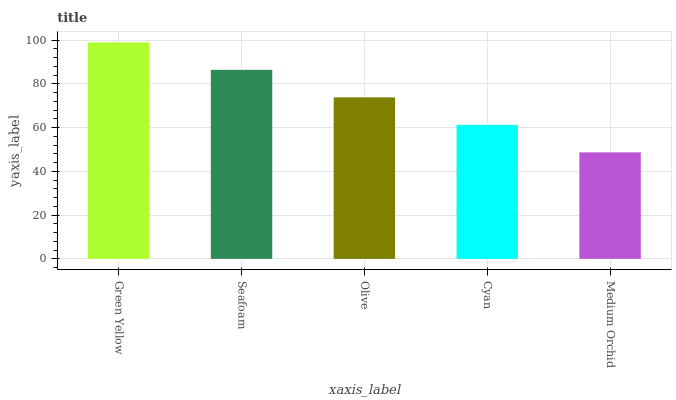Is Medium Orchid the minimum?
Answer yes or no. Yes. Is Green Yellow the maximum?
Answer yes or no. Yes. Is Seafoam the minimum?
Answer yes or no. No. Is Seafoam the maximum?
Answer yes or no. No. Is Green Yellow greater than Seafoam?
Answer yes or no. Yes. Is Seafoam less than Green Yellow?
Answer yes or no. Yes. Is Seafoam greater than Green Yellow?
Answer yes or no. No. Is Green Yellow less than Seafoam?
Answer yes or no. No. Is Olive the high median?
Answer yes or no. Yes. Is Olive the low median?
Answer yes or no. Yes. Is Medium Orchid the high median?
Answer yes or no. No. Is Medium Orchid the low median?
Answer yes or no. No. 